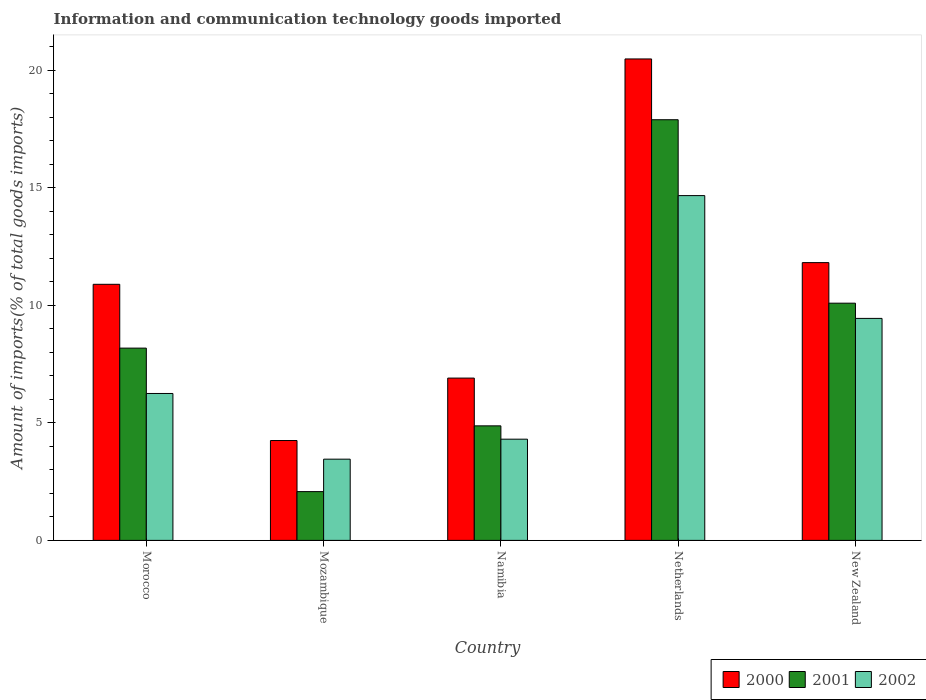Are the number of bars on each tick of the X-axis equal?
Your answer should be very brief. Yes. What is the label of the 3rd group of bars from the left?
Offer a terse response. Namibia. In how many cases, is the number of bars for a given country not equal to the number of legend labels?
Provide a short and direct response. 0. What is the amount of goods imported in 2002 in Netherlands?
Your answer should be very brief. 14.67. Across all countries, what is the maximum amount of goods imported in 2000?
Make the answer very short. 20.49. Across all countries, what is the minimum amount of goods imported in 2000?
Keep it short and to the point. 4.25. In which country was the amount of goods imported in 2000 maximum?
Provide a short and direct response. Netherlands. In which country was the amount of goods imported in 2001 minimum?
Your response must be concise. Mozambique. What is the total amount of goods imported in 2002 in the graph?
Keep it short and to the point. 38.14. What is the difference between the amount of goods imported in 2001 in Morocco and that in Netherlands?
Your response must be concise. -9.72. What is the difference between the amount of goods imported in 2000 in Netherlands and the amount of goods imported in 2001 in New Zealand?
Your response must be concise. 10.39. What is the average amount of goods imported in 2000 per country?
Provide a short and direct response. 10.87. What is the difference between the amount of goods imported of/in 2002 and amount of goods imported of/in 2001 in New Zealand?
Your response must be concise. -0.65. In how many countries, is the amount of goods imported in 2000 greater than 1 %?
Offer a terse response. 5. What is the ratio of the amount of goods imported in 2002 in Mozambique to that in Netherlands?
Ensure brevity in your answer.  0.24. Is the amount of goods imported in 2000 in Mozambique less than that in Netherlands?
Your response must be concise. Yes. What is the difference between the highest and the second highest amount of goods imported in 2001?
Ensure brevity in your answer.  -9.72. What is the difference between the highest and the lowest amount of goods imported in 2001?
Provide a short and direct response. 15.83. How many bars are there?
Your response must be concise. 15. Are all the bars in the graph horizontal?
Ensure brevity in your answer.  No. How many countries are there in the graph?
Offer a terse response. 5. Are the values on the major ticks of Y-axis written in scientific E-notation?
Offer a terse response. No. Does the graph contain grids?
Your answer should be compact. No. Where does the legend appear in the graph?
Provide a short and direct response. Bottom right. How many legend labels are there?
Your response must be concise. 3. How are the legend labels stacked?
Your response must be concise. Horizontal. What is the title of the graph?
Ensure brevity in your answer.  Information and communication technology goods imported. Does "2000" appear as one of the legend labels in the graph?
Provide a short and direct response. Yes. What is the label or title of the X-axis?
Your answer should be very brief. Country. What is the label or title of the Y-axis?
Your answer should be compact. Amount of imports(% of total goods imports). What is the Amount of imports(% of total goods imports) in 2000 in Morocco?
Make the answer very short. 10.9. What is the Amount of imports(% of total goods imports) of 2001 in Morocco?
Make the answer very short. 8.18. What is the Amount of imports(% of total goods imports) of 2002 in Morocco?
Offer a terse response. 6.25. What is the Amount of imports(% of total goods imports) in 2000 in Mozambique?
Ensure brevity in your answer.  4.25. What is the Amount of imports(% of total goods imports) in 2001 in Mozambique?
Your answer should be very brief. 2.08. What is the Amount of imports(% of total goods imports) in 2002 in Mozambique?
Ensure brevity in your answer.  3.46. What is the Amount of imports(% of total goods imports) in 2000 in Namibia?
Make the answer very short. 6.91. What is the Amount of imports(% of total goods imports) in 2001 in Namibia?
Your answer should be very brief. 4.87. What is the Amount of imports(% of total goods imports) of 2002 in Namibia?
Offer a terse response. 4.31. What is the Amount of imports(% of total goods imports) in 2000 in Netherlands?
Provide a succinct answer. 20.49. What is the Amount of imports(% of total goods imports) of 2001 in Netherlands?
Your answer should be very brief. 17.9. What is the Amount of imports(% of total goods imports) of 2002 in Netherlands?
Offer a very short reply. 14.67. What is the Amount of imports(% of total goods imports) of 2000 in New Zealand?
Provide a short and direct response. 11.82. What is the Amount of imports(% of total goods imports) of 2001 in New Zealand?
Provide a succinct answer. 10.1. What is the Amount of imports(% of total goods imports) in 2002 in New Zealand?
Provide a succinct answer. 9.45. Across all countries, what is the maximum Amount of imports(% of total goods imports) of 2000?
Provide a short and direct response. 20.49. Across all countries, what is the maximum Amount of imports(% of total goods imports) in 2001?
Offer a very short reply. 17.9. Across all countries, what is the maximum Amount of imports(% of total goods imports) of 2002?
Give a very brief answer. 14.67. Across all countries, what is the minimum Amount of imports(% of total goods imports) of 2000?
Provide a short and direct response. 4.25. Across all countries, what is the minimum Amount of imports(% of total goods imports) in 2001?
Provide a succinct answer. 2.08. Across all countries, what is the minimum Amount of imports(% of total goods imports) in 2002?
Offer a very short reply. 3.46. What is the total Amount of imports(% of total goods imports) of 2000 in the graph?
Make the answer very short. 54.37. What is the total Amount of imports(% of total goods imports) in 2001 in the graph?
Offer a very short reply. 43.13. What is the total Amount of imports(% of total goods imports) of 2002 in the graph?
Ensure brevity in your answer.  38.14. What is the difference between the Amount of imports(% of total goods imports) of 2000 in Morocco and that in Mozambique?
Keep it short and to the point. 6.65. What is the difference between the Amount of imports(% of total goods imports) in 2001 in Morocco and that in Mozambique?
Offer a terse response. 6.11. What is the difference between the Amount of imports(% of total goods imports) in 2002 in Morocco and that in Mozambique?
Offer a very short reply. 2.8. What is the difference between the Amount of imports(% of total goods imports) in 2000 in Morocco and that in Namibia?
Your answer should be very brief. 3.99. What is the difference between the Amount of imports(% of total goods imports) in 2001 in Morocco and that in Namibia?
Offer a terse response. 3.31. What is the difference between the Amount of imports(% of total goods imports) in 2002 in Morocco and that in Namibia?
Keep it short and to the point. 1.95. What is the difference between the Amount of imports(% of total goods imports) of 2000 in Morocco and that in Netherlands?
Offer a very short reply. -9.59. What is the difference between the Amount of imports(% of total goods imports) of 2001 in Morocco and that in Netherlands?
Offer a very short reply. -9.72. What is the difference between the Amount of imports(% of total goods imports) in 2002 in Morocco and that in Netherlands?
Provide a succinct answer. -8.42. What is the difference between the Amount of imports(% of total goods imports) in 2000 in Morocco and that in New Zealand?
Your answer should be compact. -0.92. What is the difference between the Amount of imports(% of total goods imports) in 2001 in Morocco and that in New Zealand?
Your answer should be compact. -1.91. What is the difference between the Amount of imports(% of total goods imports) of 2002 in Morocco and that in New Zealand?
Give a very brief answer. -3.2. What is the difference between the Amount of imports(% of total goods imports) of 2000 in Mozambique and that in Namibia?
Offer a terse response. -2.66. What is the difference between the Amount of imports(% of total goods imports) of 2001 in Mozambique and that in Namibia?
Offer a terse response. -2.8. What is the difference between the Amount of imports(% of total goods imports) of 2002 in Mozambique and that in Namibia?
Your answer should be compact. -0.85. What is the difference between the Amount of imports(% of total goods imports) in 2000 in Mozambique and that in Netherlands?
Your answer should be compact. -16.24. What is the difference between the Amount of imports(% of total goods imports) of 2001 in Mozambique and that in Netherlands?
Your answer should be compact. -15.83. What is the difference between the Amount of imports(% of total goods imports) in 2002 in Mozambique and that in Netherlands?
Ensure brevity in your answer.  -11.22. What is the difference between the Amount of imports(% of total goods imports) in 2000 in Mozambique and that in New Zealand?
Give a very brief answer. -7.57. What is the difference between the Amount of imports(% of total goods imports) of 2001 in Mozambique and that in New Zealand?
Provide a succinct answer. -8.02. What is the difference between the Amount of imports(% of total goods imports) of 2002 in Mozambique and that in New Zealand?
Offer a very short reply. -5.99. What is the difference between the Amount of imports(% of total goods imports) of 2000 in Namibia and that in Netherlands?
Your response must be concise. -13.58. What is the difference between the Amount of imports(% of total goods imports) in 2001 in Namibia and that in Netherlands?
Offer a terse response. -13.03. What is the difference between the Amount of imports(% of total goods imports) of 2002 in Namibia and that in Netherlands?
Keep it short and to the point. -10.37. What is the difference between the Amount of imports(% of total goods imports) of 2000 in Namibia and that in New Zealand?
Offer a very short reply. -4.91. What is the difference between the Amount of imports(% of total goods imports) of 2001 in Namibia and that in New Zealand?
Your answer should be very brief. -5.22. What is the difference between the Amount of imports(% of total goods imports) of 2002 in Namibia and that in New Zealand?
Provide a short and direct response. -5.14. What is the difference between the Amount of imports(% of total goods imports) in 2000 in Netherlands and that in New Zealand?
Give a very brief answer. 8.67. What is the difference between the Amount of imports(% of total goods imports) of 2001 in Netherlands and that in New Zealand?
Offer a terse response. 7.81. What is the difference between the Amount of imports(% of total goods imports) in 2002 in Netherlands and that in New Zealand?
Your response must be concise. 5.23. What is the difference between the Amount of imports(% of total goods imports) in 2000 in Morocco and the Amount of imports(% of total goods imports) in 2001 in Mozambique?
Offer a very short reply. 8.82. What is the difference between the Amount of imports(% of total goods imports) in 2000 in Morocco and the Amount of imports(% of total goods imports) in 2002 in Mozambique?
Give a very brief answer. 7.44. What is the difference between the Amount of imports(% of total goods imports) in 2001 in Morocco and the Amount of imports(% of total goods imports) in 2002 in Mozambique?
Make the answer very short. 4.73. What is the difference between the Amount of imports(% of total goods imports) in 2000 in Morocco and the Amount of imports(% of total goods imports) in 2001 in Namibia?
Offer a terse response. 6.02. What is the difference between the Amount of imports(% of total goods imports) of 2000 in Morocco and the Amount of imports(% of total goods imports) of 2002 in Namibia?
Make the answer very short. 6.59. What is the difference between the Amount of imports(% of total goods imports) in 2001 in Morocco and the Amount of imports(% of total goods imports) in 2002 in Namibia?
Your response must be concise. 3.88. What is the difference between the Amount of imports(% of total goods imports) in 2000 in Morocco and the Amount of imports(% of total goods imports) in 2001 in Netherlands?
Offer a very short reply. -7. What is the difference between the Amount of imports(% of total goods imports) in 2000 in Morocco and the Amount of imports(% of total goods imports) in 2002 in Netherlands?
Keep it short and to the point. -3.77. What is the difference between the Amount of imports(% of total goods imports) in 2001 in Morocco and the Amount of imports(% of total goods imports) in 2002 in Netherlands?
Provide a short and direct response. -6.49. What is the difference between the Amount of imports(% of total goods imports) in 2000 in Morocco and the Amount of imports(% of total goods imports) in 2001 in New Zealand?
Give a very brief answer. 0.8. What is the difference between the Amount of imports(% of total goods imports) of 2000 in Morocco and the Amount of imports(% of total goods imports) of 2002 in New Zealand?
Make the answer very short. 1.45. What is the difference between the Amount of imports(% of total goods imports) in 2001 in Morocco and the Amount of imports(% of total goods imports) in 2002 in New Zealand?
Offer a terse response. -1.26. What is the difference between the Amount of imports(% of total goods imports) of 2000 in Mozambique and the Amount of imports(% of total goods imports) of 2001 in Namibia?
Provide a succinct answer. -0.62. What is the difference between the Amount of imports(% of total goods imports) of 2000 in Mozambique and the Amount of imports(% of total goods imports) of 2002 in Namibia?
Offer a very short reply. -0.06. What is the difference between the Amount of imports(% of total goods imports) in 2001 in Mozambique and the Amount of imports(% of total goods imports) in 2002 in Namibia?
Ensure brevity in your answer.  -2.23. What is the difference between the Amount of imports(% of total goods imports) in 2000 in Mozambique and the Amount of imports(% of total goods imports) in 2001 in Netherlands?
Provide a short and direct response. -13.65. What is the difference between the Amount of imports(% of total goods imports) in 2000 in Mozambique and the Amount of imports(% of total goods imports) in 2002 in Netherlands?
Your answer should be very brief. -10.42. What is the difference between the Amount of imports(% of total goods imports) of 2001 in Mozambique and the Amount of imports(% of total goods imports) of 2002 in Netherlands?
Give a very brief answer. -12.6. What is the difference between the Amount of imports(% of total goods imports) of 2000 in Mozambique and the Amount of imports(% of total goods imports) of 2001 in New Zealand?
Your answer should be very brief. -5.84. What is the difference between the Amount of imports(% of total goods imports) in 2000 in Mozambique and the Amount of imports(% of total goods imports) in 2002 in New Zealand?
Provide a short and direct response. -5.2. What is the difference between the Amount of imports(% of total goods imports) of 2001 in Mozambique and the Amount of imports(% of total goods imports) of 2002 in New Zealand?
Your answer should be compact. -7.37. What is the difference between the Amount of imports(% of total goods imports) of 2000 in Namibia and the Amount of imports(% of total goods imports) of 2001 in Netherlands?
Offer a very short reply. -11. What is the difference between the Amount of imports(% of total goods imports) in 2000 in Namibia and the Amount of imports(% of total goods imports) in 2002 in Netherlands?
Ensure brevity in your answer.  -7.77. What is the difference between the Amount of imports(% of total goods imports) in 2001 in Namibia and the Amount of imports(% of total goods imports) in 2002 in Netherlands?
Offer a terse response. -9.8. What is the difference between the Amount of imports(% of total goods imports) in 2000 in Namibia and the Amount of imports(% of total goods imports) in 2001 in New Zealand?
Provide a short and direct response. -3.19. What is the difference between the Amount of imports(% of total goods imports) in 2000 in Namibia and the Amount of imports(% of total goods imports) in 2002 in New Zealand?
Ensure brevity in your answer.  -2.54. What is the difference between the Amount of imports(% of total goods imports) in 2001 in Namibia and the Amount of imports(% of total goods imports) in 2002 in New Zealand?
Your response must be concise. -4.57. What is the difference between the Amount of imports(% of total goods imports) in 2000 in Netherlands and the Amount of imports(% of total goods imports) in 2001 in New Zealand?
Your answer should be very brief. 10.39. What is the difference between the Amount of imports(% of total goods imports) in 2000 in Netherlands and the Amount of imports(% of total goods imports) in 2002 in New Zealand?
Your answer should be very brief. 11.04. What is the difference between the Amount of imports(% of total goods imports) in 2001 in Netherlands and the Amount of imports(% of total goods imports) in 2002 in New Zealand?
Provide a short and direct response. 8.46. What is the average Amount of imports(% of total goods imports) of 2000 per country?
Offer a terse response. 10.87. What is the average Amount of imports(% of total goods imports) in 2001 per country?
Provide a short and direct response. 8.63. What is the average Amount of imports(% of total goods imports) in 2002 per country?
Your answer should be compact. 7.63. What is the difference between the Amount of imports(% of total goods imports) in 2000 and Amount of imports(% of total goods imports) in 2001 in Morocco?
Provide a succinct answer. 2.72. What is the difference between the Amount of imports(% of total goods imports) of 2000 and Amount of imports(% of total goods imports) of 2002 in Morocco?
Give a very brief answer. 4.65. What is the difference between the Amount of imports(% of total goods imports) of 2001 and Amount of imports(% of total goods imports) of 2002 in Morocco?
Offer a terse response. 1.93. What is the difference between the Amount of imports(% of total goods imports) in 2000 and Amount of imports(% of total goods imports) in 2001 in Mozambique?
Your response must be concise. 2.17. What is the difference between the Amount of imports(% of total goods imports) in 2000 and Amount of imports(% of total goods imports) in 2002 in Mozambique?
Provide a short and direct response. 0.79. What is the difference between the Amount of imports(% of total goods imports) in 2001 and Amount of imports(% of total goods imports) in 2002 in Mozambique?
Your answer should be very brief. -1.38. What is the difference between the Amount of imports(% of total goods imports) in 2000 and Amount of imports(% of total goods imports) in 2001 in Namibia?
Ensure brevity in your answer.  2.03. What is the difference between the Amount of imports(% of total goods imports) of 2000 and Amount of imports(% of total goods imports) of 2002 in Namibia?
Give a very brief answer. 2.6. What is the difference between the Amount of imports(% of total goods imports) in 2001 and Amount of imports(% of total goods imports) in 2002 in Namibia?
Offer a terse response. 0.57. What is the difference between the Amount of imports(% of total goods imports) in 2000 and Amount of imports(% of total goods imports) in 2001 in Netherlands?
Offer a terse response. 2.59. What is the difference between the Amount of imports(% of total goods imports) of 2000 and Amount of imports(% of total goods imports) of 2002 in Netherlands?
Offer a terse response. 5.82. What is the difference between the Amount of imports(% of total goods imports) of 2001 and Amount of imports(% of total goods imports) of 2002 in Netherlands?
Give a very brief answer. 3.23. What is the difference between the Amount of imports(% of total goods imports) in 2000 and Amount of imports(% of total goods imports) in 2001 in New Zealand?
Offer a terse response. 1.73. What is the difference between the Amount of imports(% of total goods imports) in 2000 and Amount of imports(% of total goods imports) in 2002 in New Zealand?
Offer a very short reply. 2.37. What is the difference between the Amount of imports(% of total goods imports) in 2001 and Amount of imports(% of total goods imports) in 2002 in New Zealand?
Make the answer very short. 0.65. What is the ratio of the Amount of imports(% of total goods imports) of 2000 in Morocco to that in Mozambique?
Provide a succinct answer. 2.56. What is the ratio of the Amount of imports(% of total goods imports) in 2001 in Morocco to that in Mozambique?
Give a very brief answer. 3.94. What is the ratio of the Amount of imports(% of total goods imports) in 2002 in Morocco to that in Mozambique?
Keep it short and to the point. 1.81. What is the ratio of the Amount of imports(% of total goods imports) in 2000 in Morocco to that in Namibia?
Offer a terse response. 1.58. What is the ratio of the Amount of imports(% of total goods imports) of 2001 in Morocco to that in Namibia?
Your answer should be very brief. 1.68. What is the ratio of the Amount of imports(% of total goods imports) in 2002 in Morocco to that in Namibia?
Keep it short and to the point. 1.45. What is the ratio of the Amount of imports(% of total goods imports) of 2000 in Morocco to that in Netherlands?
Provide a short and direct response. 0.53. What is the ratio of the Amount of imports(% of total goods imports) in 2001 in Morocco to that in Netherlands?
Give a very brief answer. 0.46. What is the ratio of the Amount of imports(% of total goods imports) of 2002 in Morocco to that in Netherlands?
Provide a succinct answer. 0.43. What is the ratio of the Amount of imports(% of total goods imports) in 2000 in Morocco to that in New Zealand?
Your answer should be compact. 0.92. What is the ratio of the Amount of imports(% of total goods imports) in 2001 in Morocco to that in New Zealand?
Your response must be concise. 0.81. What is the ratio of the Amount of imports(% of total goods imports) of 2002 in Morocco to that in New Zealand?
Give a very brief answer. 0.66. What is the ratio of the Amount of imports(% of total goods imports) of 2000 in Mozambique to that in Namibia?
Provide a succinct answer. 0.62. What is the ratio of the Amount of imports(% of total goods imports) in 2001 in Mozambique to that in Namibia?
Provide a succinct answer. 0.43. What is the ratio of the Amount of imports(% of total goods imports) in 2002 in Mozambique to that in Namibia?
Offer a terse response. 0.8. What is the ratio of the Amount of imports(% of total goods imports) of 2000 in Mozambique to that in Netherlands?
Offer a very short reply. 0.21. What is the ratio of the Amount of imports(% of total goods imports) in 2001 in Mozambique to that in Netherlands?
Offer a terse response. 0.12. What is the ratio of the Amount of imports(% of total goods imports) in 2002 in Mozambique to that in Netherlands?
Make the answer very short. 0.24. What is the ratio of the Amount of imports(% of total goods imports) in 2000 in Mozambique to that in New Zealand?
Give a very brief answer. 0.36. What is the ratio of the Amount of imports(% of total goods imports) in 2001 in Mozambique to that in New Zealand?
Your response must be concise. 0.21. What is the ratio of the Amount of imports(% of total goods imports) in 2002 in Mozambique to that in New Zealand?
Make the answer very short. 0.37. What is the ratio of the Amount of imports(% of total goods imports) in 2000 in Namibia to that in Netherlands?
Keep it short and to the point. 0.34. What is the ratio of the Amount of imports(% of total goods imports) of 2001 in Namibia to that in Netherlands?
Keep it short and to the point. 0.27. What is the ratio of the Amount of imports(% of total goods imports) in 2002 in Namibia to that in Netherlands?
Offer a very short reply. 0.29. What is the ratio of the Amount of imports(% of total goods imports) of 2000 in Namibia to that in New Zealand?
Offer a very short reply. 0.58. What is the ratio of the Amount of imports(% of total goods imports) in 2001 in Namibia to that in New Zealand?
Ensure brevity in your answer.  0.48. What is the ratio of the Amount of imports(% of total goods imports) in 2002 in Namibia to that in New Zealand?
Offer a very short reply. 0.46. What is the ratio of the Amount of imports(% of total goods imports) of 2000 in Netherlands to that in New Zealand?
Provide a succinct answer. 1.73. What is the ratio of the Amount of imports(% of total goods imports) of 2001 in Netherlands to that in New Zealand?
Keep it short and to the point. 1.77. What is the ratio of the Amount of imports(% of total goods imports) of 2002 in Netherlands to that in New Zealand?
Give a very brief answer. 1.55. What is the difference between the highest and the second highest Amount of imports(% of total goods imports) in 2000?
Give a very brief answer. 8.67. What is the difference between the highest and the second highest Amount of imports(% of total goods imports) in 2001?
Give a very brief answer. 7.81. What is the difference between the highest and the second highest Amount of imports(% of total goods imports) of 2002?
Offer a very short reply. 5.23. What is the difference between the highest and the lowest Amount of imports(% of total goods imports) of 2000?
Ensure brevity in your answer.  16.24. What is the difference between the highest and the lowest Amount of imports(% of total goods imports) in 2001?
Keep it short and to the point. 15.83. What is the difference between the highest and the lowest Amount of imports(% of total goods imports) in 2002?
Ensure brevity in your answer.  11.22. 